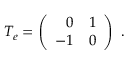<formula> <loc_0><loc_0><loc_500><loc_500>T _ { e } = \left ( \begin{array} { r r } { 0 } & { 1 } \\ { - 1 } & { 0 } \end{array} \right ) \ .</formula> 